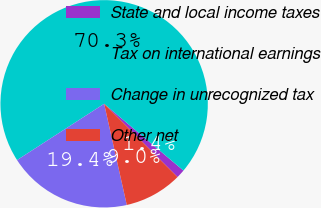Convert chart. <chart><loc_0><loc_0><loc_500><loc_500><pie_chart><fcel>State and local income taxes<fcel>Tax on international earnings<fcel>Change in unrecognized tax<fcel>Other net<nl><fcel>1.35%<fcel>70.27%<fcel>19.37%<fcel>9.01%<nl></chart> 